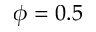<formula> <loc_0><loc_0><loc_500><loc_500>\phi = 0 . 5</formula> 